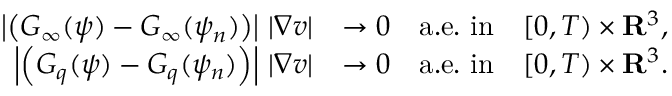Convert formula to latex. <formula><loc_0><loc_0><loc_500><loc_500>\begin{array} { r l } { \left | \left ( G _ { \infty } ( \psi ) - G _ { \infty } ( \psi _ { n } ) \right ) \right | \, | \nabla v | } & { \rightarrow 0 \quad a . e . i n \quad [ 0 , T ) \times { \mathbf R } ^ { 3 } , } \\ { \left | \left ( G _ { q } ( \psi ) - G _ { q } ( \psi _ { n } ) \right ) \right | \, | \nabla v | } & { \rightarrow 0 \quad a . e . i n \quad [ 0 , T ) \times { \mathbf R } ^ { 3 } . } \end{array}</formula> 